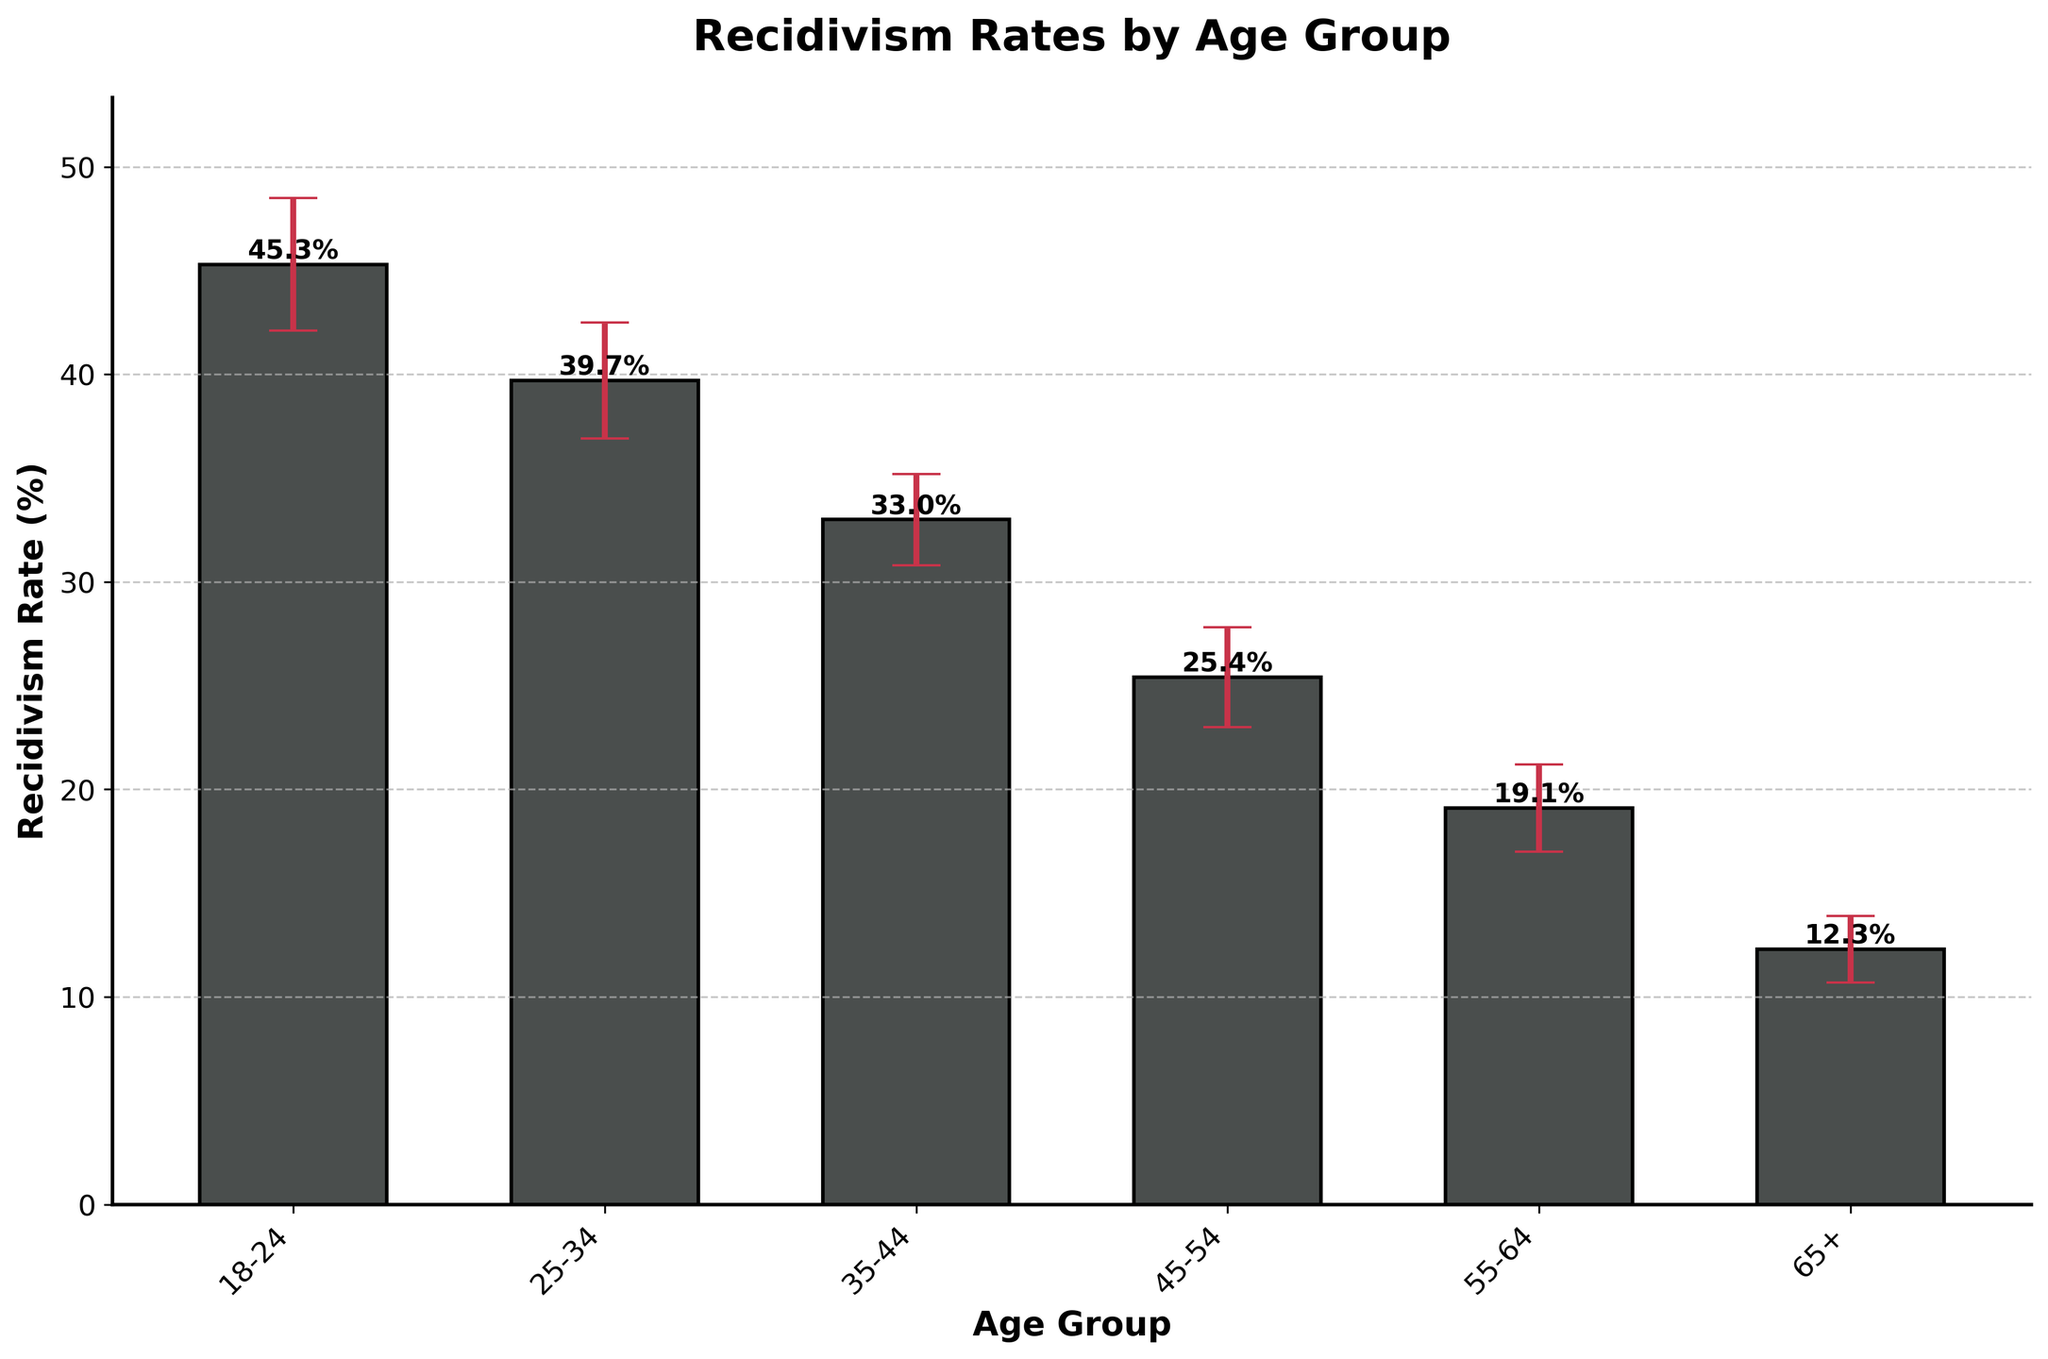Which age group has the highest recidivism rate? The age group with the highest bar represents the highest recidivism rate. The 18-24 age group's bar is the tallest.
Answer: 18-24 Which age group has the lowest recidivism rate? The age group with the shortest bar represents the lowest recidivism rate. The 65+ age group's bar is the shortest.
Answer: 65+ What is the recidivism rate for the 25-34 age group? Locate the bar for the 25-34 age group and read its height value, which is 39.7%.
Answer: 39.7% How does the recidivism rate change as age increases from 18-24 to 25-34? Compare the bars for the 18-24 and 25-34 age groups. The rate decreases from 45.3% to 39.7%.
Answer: Decreases What is the range of the confidence interval for the 35-44 age group? The upper CI is 35.2% and the lower CI is 30.8%, thus the range is 35.2% - 30.8% = 4.4%.
Answer: 4.4% Which two age groups have the most similar recidivism rates? Compare the heights of all the bars. The 25-34 and 35-44 age groups have the closest rates, 39.7% and 33.0%, respectively.
Answer: 25-34 and 35-44 How do the error bars for the 18-24 and 65+ age groups compare? Observe the length of the error bars for both groups. The 18-24 group has longer error bars (6.4%) compared to the 65+ group (3.2%).
Answer: 18-24 error bars are longer What is the average recidivism rate across all age groups? Sum all recidivism rates (45.3 + 39.7 + 33.0 + 25.4 + 19.1 + 12.3) = 174.8, and divide by the number of groups (6). 174.8 / 6 = 29.13%.
Answer: 29.13% Which age group has the narrowest confidence interval? Compare the width of the confidence intervals by subtracting the lower CI from the upper CI for each group. The 65+ group has the narrowest interval, 13.9% - 10.7% = 3.2%.
Answer: 65+ What is the difference in recidivism rate between the 45-54 and 55-64 age groups? Subtract the rate of the 55-64 group from the 45-54 group (25.4% - 19.1%) = 6.3%.
Answer: 6.3% 